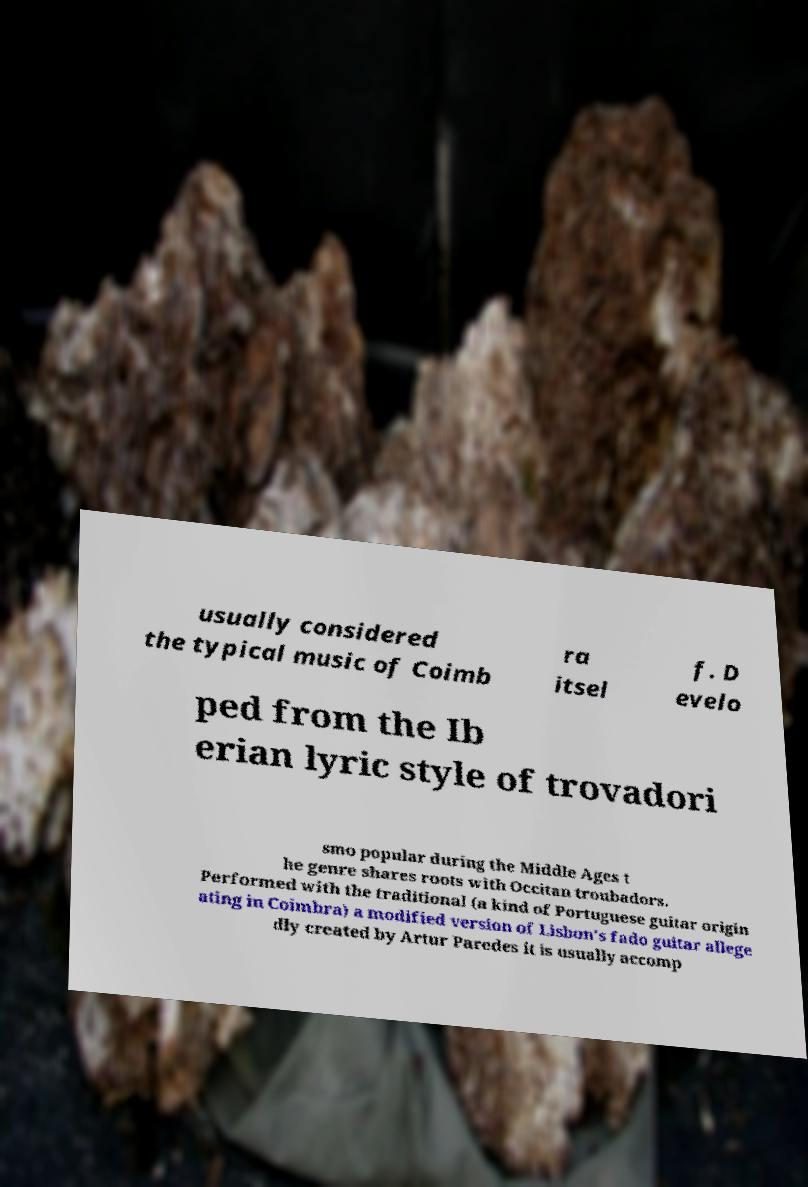Can you accurately transcribe the text from the provided image for me? usually considered the typical music of Coimb ra itsel f. D evelo ped from the Ib erian lyric style of trovadori smo popular during the Middle Ages t he genre shares roots with Occitan troubadors. Performed with the traditional (a kind of Portuguese guitar origin ating in Coimbra) a modified version of Lisbon's fado guitar allege dly created by Artur Paredes it is usually accomp 